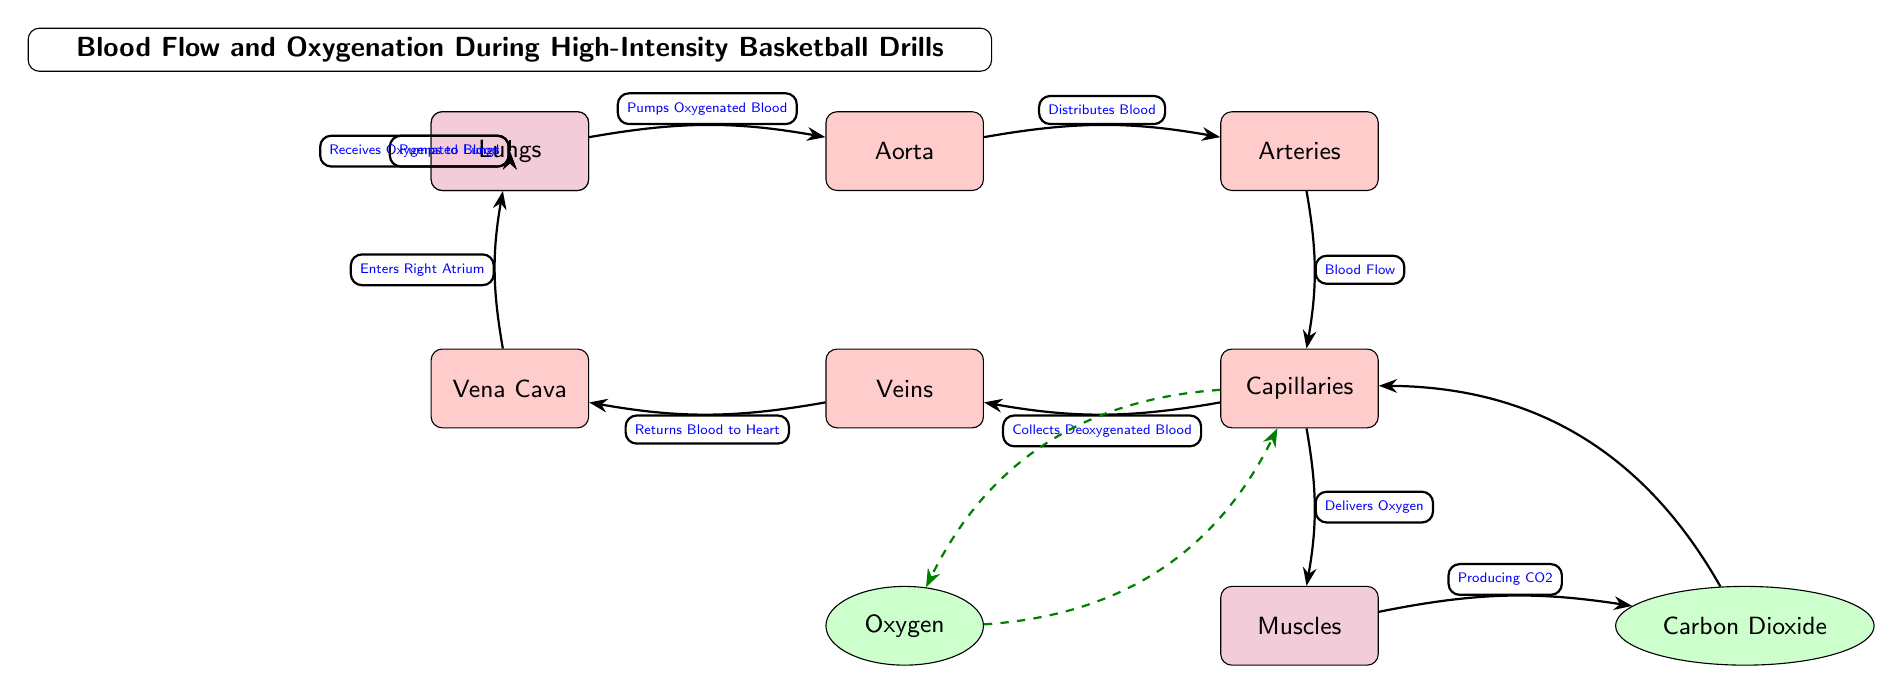What is the main organ involved in pumping blood? The diagram shows the heart as the starting point, indicated by the label "Heart," which is responsible for pumping oxygenated blood.
Answer: Heart What follows after the aorta? The diagram shows an arrow from the aorta to the arteries, indicating the flow of blood.
Answer: Arteries How does oxygen reach the muscles? The diagram outlines that blood flows from the capillaries directly to the muscles with the label "Delivers Oxygen."
Answer: Delivers Oxygen What gas is produced by the muscles during high-intensity drills? According to the diagram, the muscles produce carbon dioxide as indicated by “Producing CO2.”
Answer: Carbon Dioxide How does blood return to the heart after circulating through the body? The diagram illustrates that the veins collect deoxygenated blood and return it to the vena cava, which then enters the heart, indicated by the arrows and labels.
Answer: Returns Blood to Heart What is the process that occurs at the lungs? The diagram shows that the heart pumps blood to the lungs where it receives oxygenated blood, denoted with the label "Receives Oxygenated Blood."
Answer: Receives Oxygenated Blood How many types of gas are shown in the diagram? The diagram depicts two types of gases: oxygen and carbon dioxide. Counting them results in a total of two.
Answer: 2 What type of blood flows through the vena cava? The diagram indicates that the vena cava is the vessel that returns deoxygenated blood to the heart.
Answer: Deoxygenated Blood What edge labels indicate the roles of the heart? The diagram specifies two roles for the heart: "Pumps Oxygenated Blood" and "Pumps to Lungs," showing its functions clearly at different connections.
Answer: Pumps Oxygenated Blood, Pumps to Lungs 